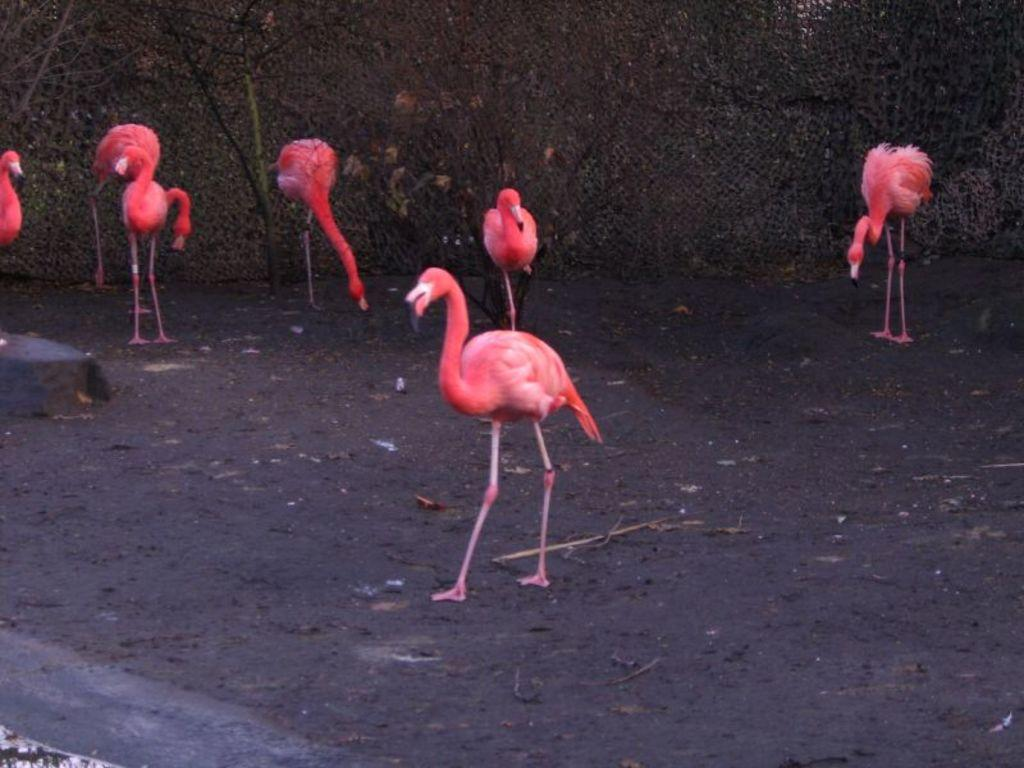Where was the picture taken? The picture was taken outside. What is the main subject of the image? There is a group of flamingos in the center of the image. What are the flamingos doing in the image? The flamingos are standing on the ground. What can be seen in the background of the image? There are trees visible in the background of the image, as well as other unspecified objects. How many lizards are sitting on the plate in the image? There are no lizards or plates present in the image; it features a group of flamingos standing on the ground. What type of patch is visible on the flamingo's wing in the image? There is no patch visible on the flamingos' wings in the image. 